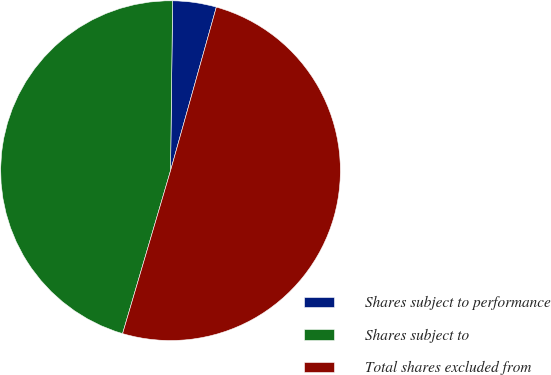Convert chart to OTSL. <chart><loc_0><loc_0><loc_500><loc_500><pie_chart><fcel>Shares subject to performance<fcel>Shares subject to<fcel>Total shares excluded from<nl><fcel>4.15%<fcel>45.64%<fcel>50.21%<nl></chart> 